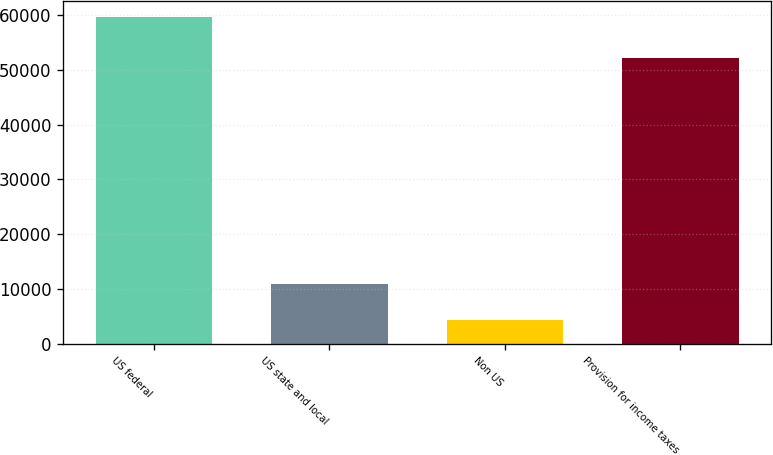<chart> <loc_0><loc_0><loc_500><loc_500><bar_chart><fcel>US federal<fcel>US state and local<fcel>Non US<fcel>Provision for income taxes<nl><fcel>59608<fcel>10886<fcel>4261<fcel>52181<nl></chart> 